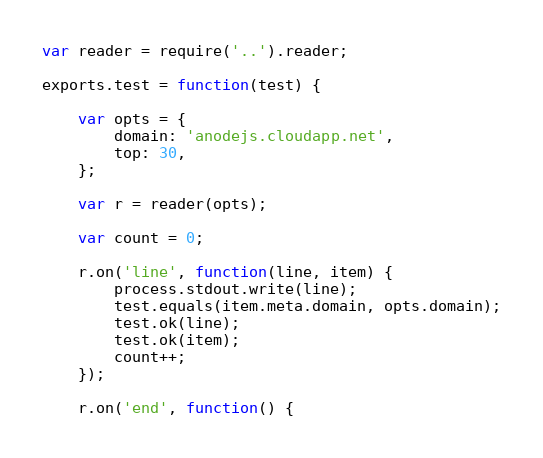Convert code to text. <code><loc_0><loc_0><loc_500><loc_500><_JavaScript_>var reader = require('..').reader;

exports.test = function(test) {

	var opts = {
		domain: 'anodejs.cloudapp.net',
		top: 30,
	};

	var r = reader(opts);

	var count = 0;

	r.on('line', function(line, item) {
		process.stdout.write(line);
		test.equals(item.meta.domain, opts.domain);
		test.ok(line);
		test.ok(item);
		count++;
	});

	r.on('end', function() {  </code> 